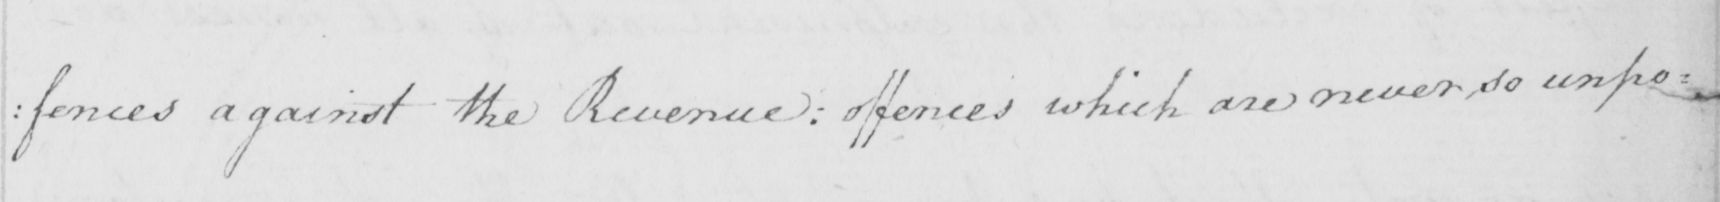What text is written in this handwritten line? : fences against the Revenue :  offences which are never so unpo= 